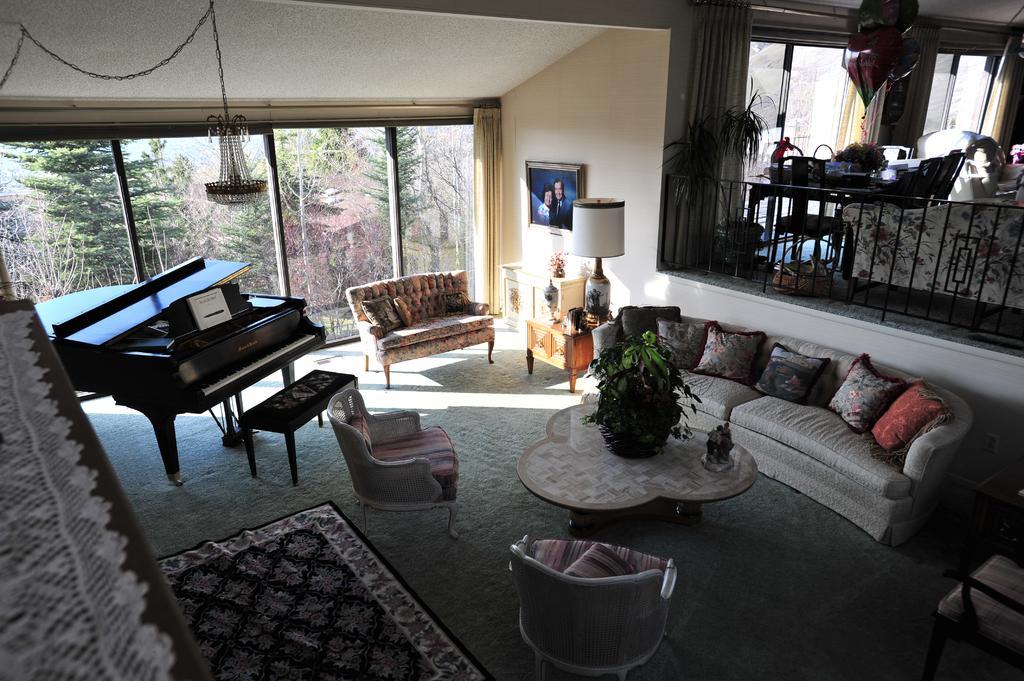Could you give a brief overview of what you see in this image? In this image I see a room and there is a piano over here, a sofa set, a table and there is a plant on it and a lamp and on the wall there is a photo frame. In the background I can see lot of trees and there is furniture over here. 